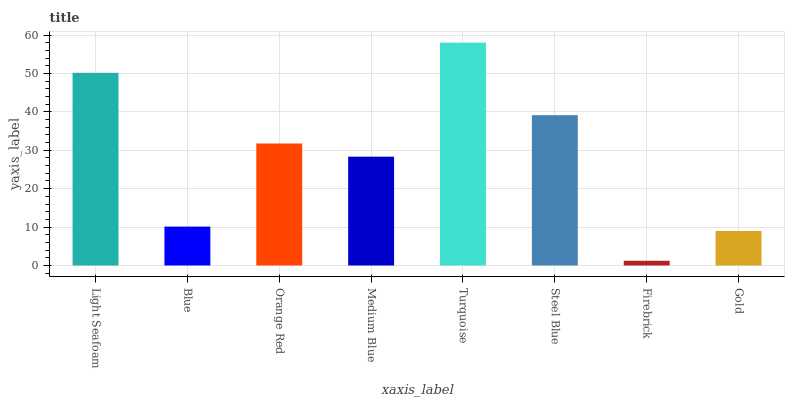Is Blue the minimum?
Answer yes or no. No. Is Blue the maximum?
Answer yes or no. No. Is Light Seafoam greater than Blue?
Answer yes or no. Yes. Is Blue less than Light Seafoam?
Answer yes or no. Yes. Is Blue greater than Light Seafoam?
Answer yes or no. No. Is Light Seafoam less than Blue?
Answer yes or no. No. Is Orange Red the high median?
Answer yes or no. Yes. Is Medium Blue the low median?
Answer yes or no. Yes. Is Turquoise the high median?
Answer yes or no. No. Is Blue the low median?
Answer yes or no. No. 